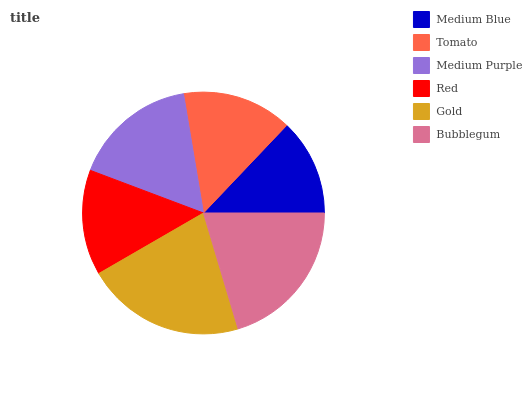Is Medium Blue the minimum?
Answer yes or no. Yes. Is Gold the maximum?
Answer yes or no. Yes. Is Tomato the minimum?
Answer yes or no. No. Is Tomato the maximum?
Answer yes or no. No. Is Tomato greater than Medium Blue?
Answer yes or no. Yes. Is Medium Blue less than Tomato?
Answer yes or no. Yes. Is Medium Blue greater than Tomato?
Answer yes or no. No. Is Tomato less than Medium Blue?
Answer yes or no. No. Is Medium Purple the high median?
Answer yes or no. Yes. Is Tomato the low median?
Answer yes or no. Yes. Is Medium Blue the high median?
Answer yes or no. No. Is Gold the low median?
Answer yes or no. No. 